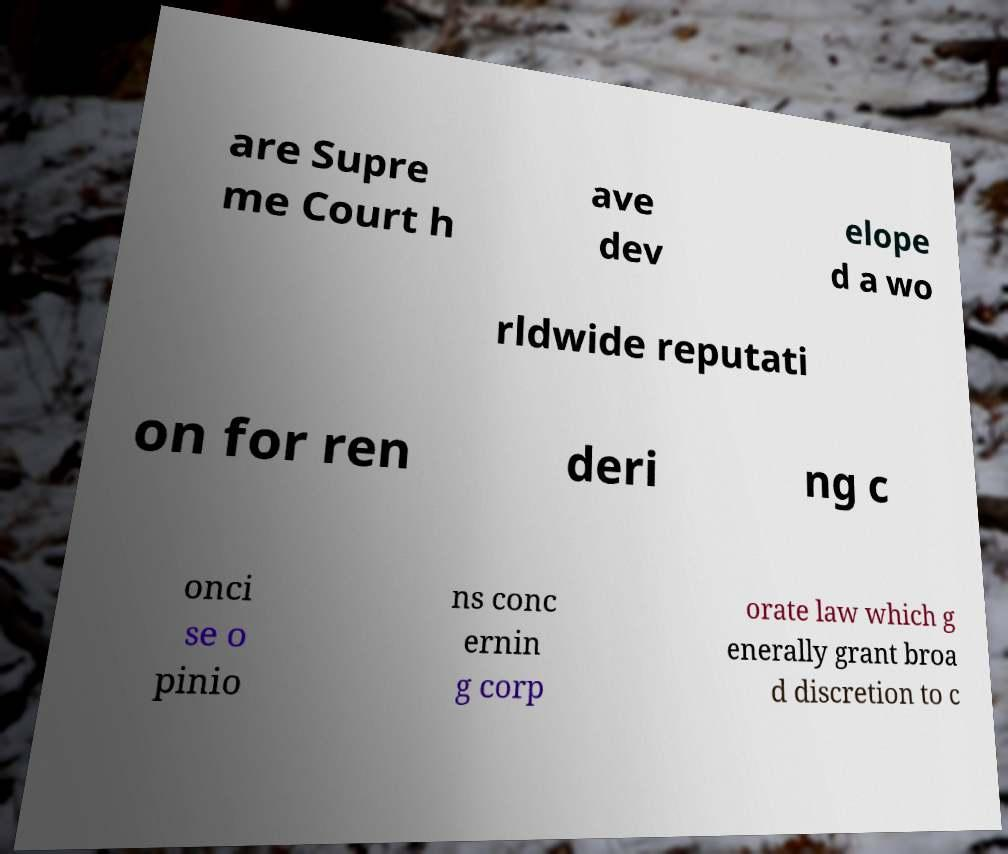Could you extract and type out the text from this image? are Supre me Court h ave dev elope d a wo rldwide reputati on for ren deri ng c onci se o pinio ns conc ernin g corp orate law which g enerally grant broa d discretion to c 